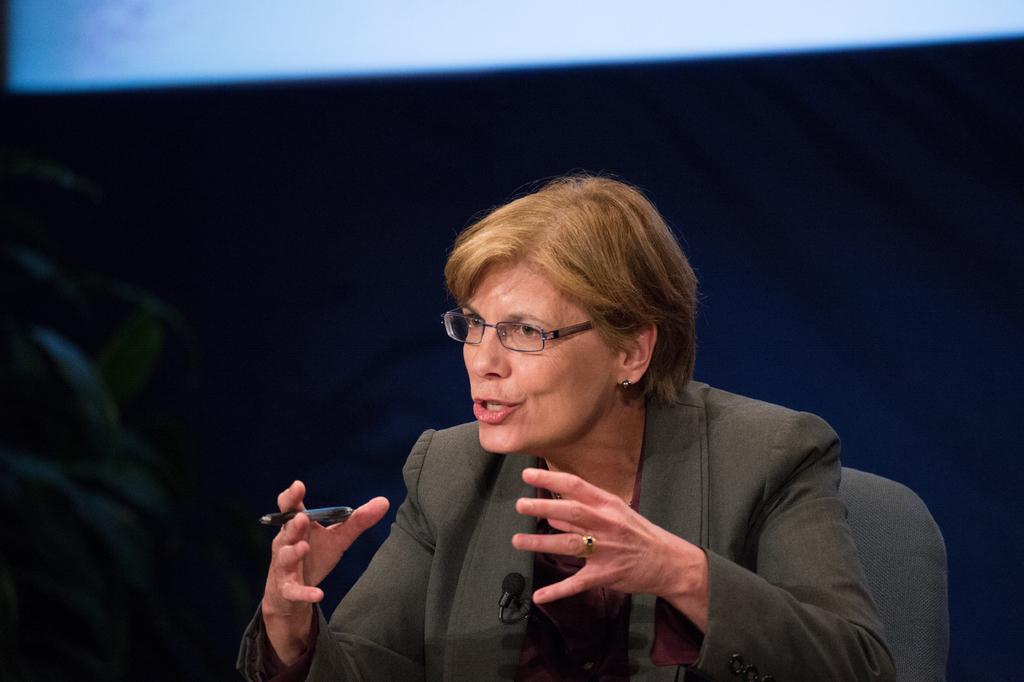Please provide a concise description of this image. In this image I can see a woman with a pen explaining something and I can see a mike on her jacket. 